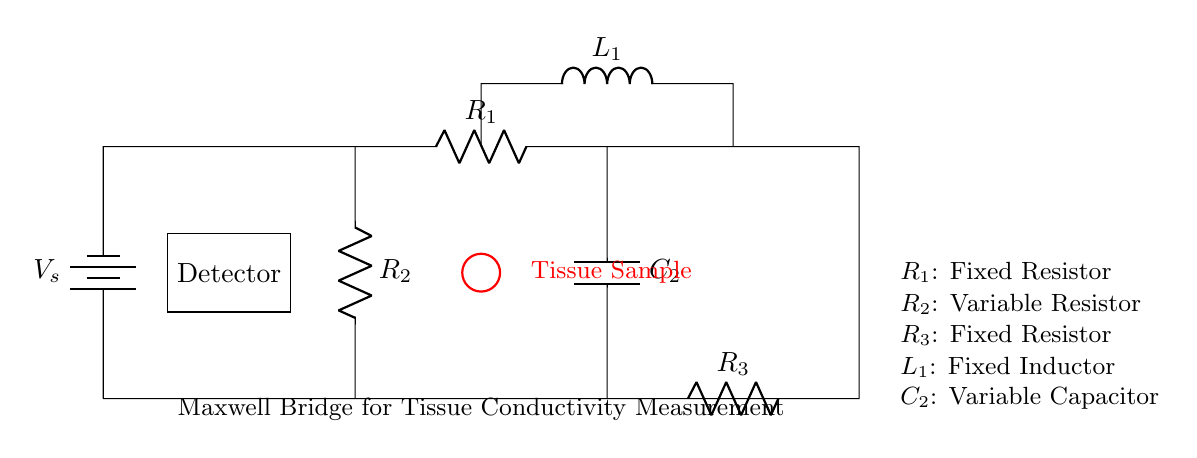What is the component labeled as R2? R2 is described as a variable resistor in the circuit diagram, indicated by its label.
Answer: Variable Resistor What is the function of the capacitor C2 in this circuit? Capacitor C2, as shown in the circuit, is a variable capacitor, which suggests it is used for tuning the bridge circuit to achieve balance or to measure changes in the tissue conductivity accurately.
Answer: Tuning/Conductivity Measurement How many resistors are present in the circuit? The circuit diagram includes three resistors labeled as R1, R2, and R3, as inferred from the labels visible in the representation of the circuit.
Answer: Three What is the expected signal output from the detector? The detector typically outputs a signal when the bridge is balanced, indicating that the resistance of the tissue sample is equal to the reference resistance, which can then be quantified.
Answer: Voltage Signal Which component is used to represent the tissue sample? The tissue sample in the circuit is represented by a red circle labeled in the diagram, which indicates its relevance in measuring changes in conductivity.
Answer: Tissue Sample What behavior is expected when the tissue conductivity changes? When the conductivity of the tissue changes, it will alter the balance of the bridge circuit, leading to a measurable change in the output signal at the detector.
Answer: Change in Output Signal What type of circuit is illustrated in the diagram? The circuit is specifically designed as a Maxwell bridge, recognized for measuring unknown impedances such as tissue conductivity by balancing the bridge with known values.
Answer: Maxwell Bridge 